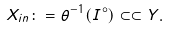<formula> <loc_0><loc_0><loc_500><loc_500>X _ { i n } \colon = \theta ^ { - 1 } ( I ^ { \circ } ) \subset \subset Y .</formula> 